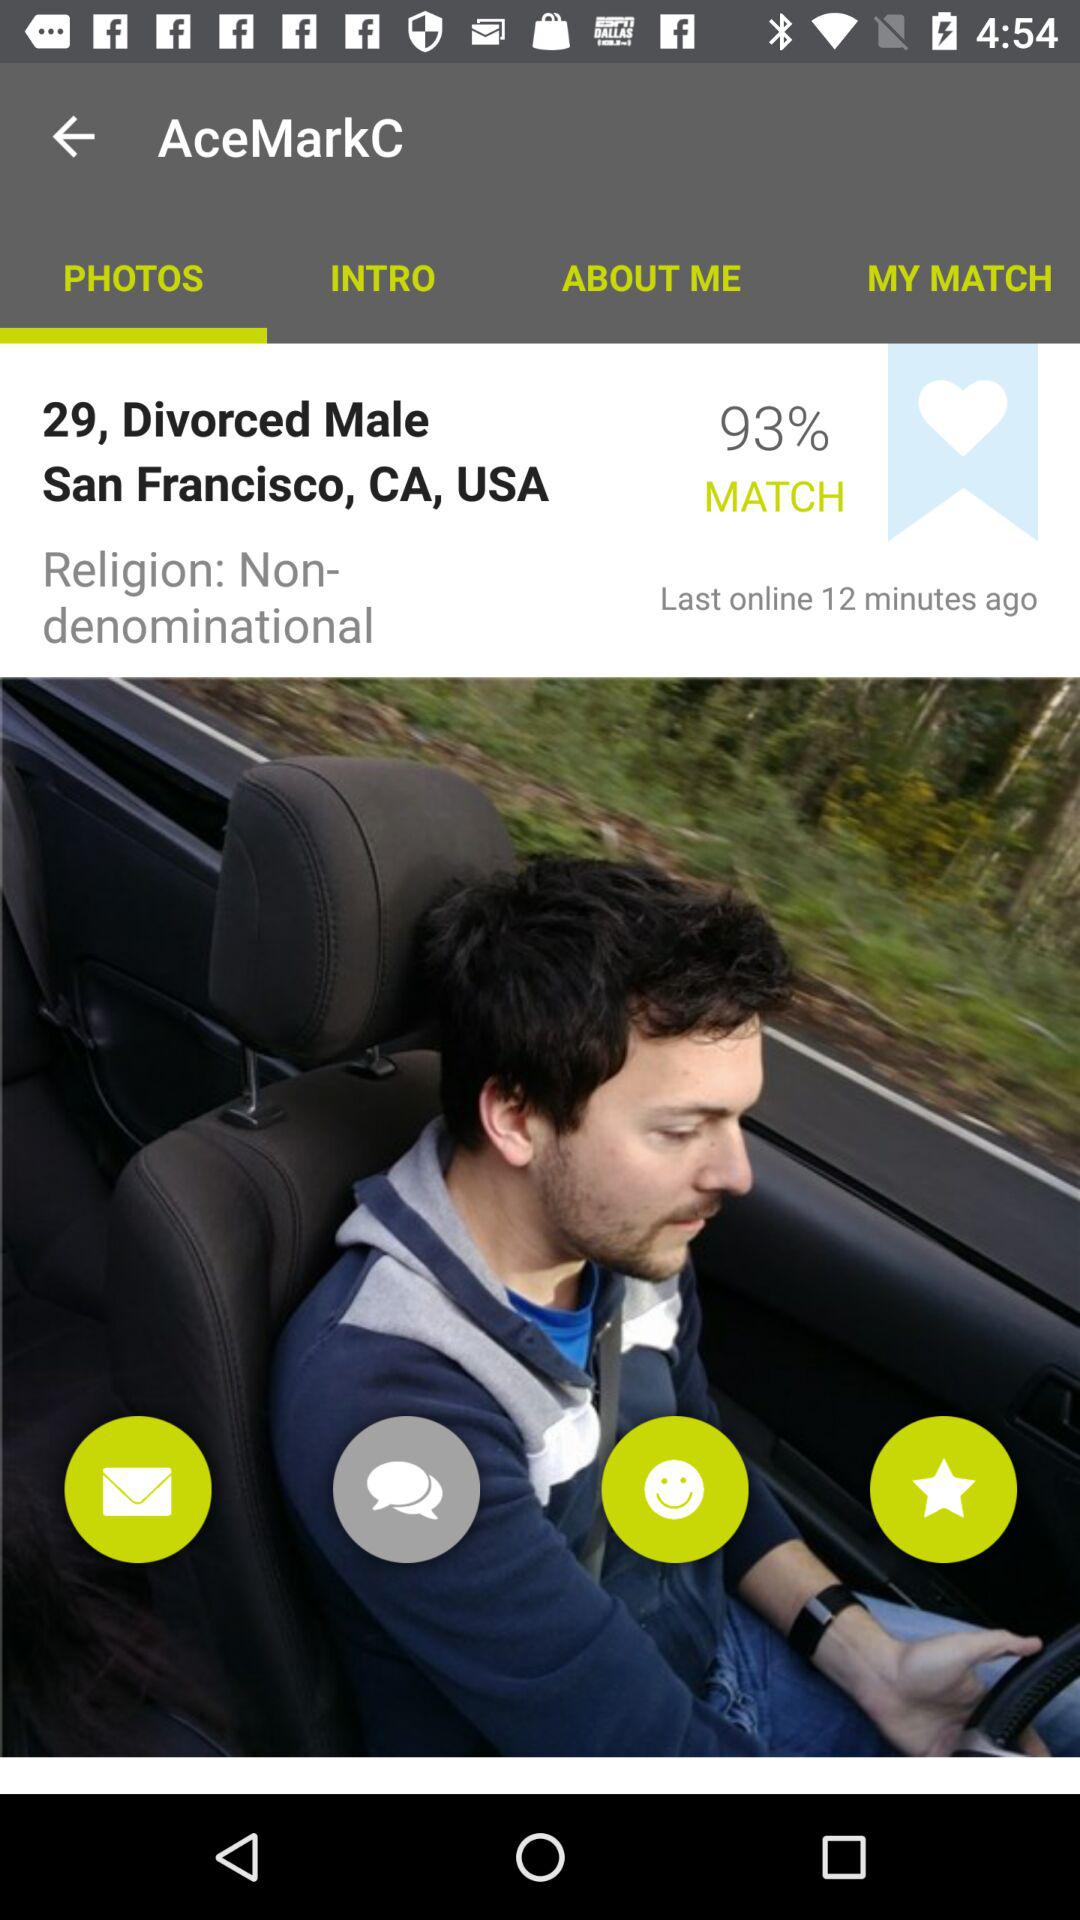What is the religion of the user? The religion of the user is Non-denominational. 